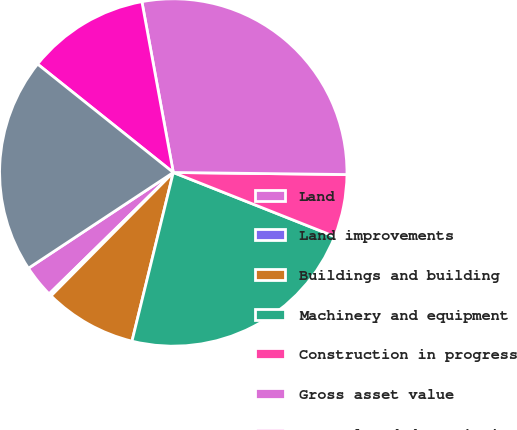<chart> <loc_0><loc_0><loc_500><loc_500><pie_chart><fcel>Land<fcel>Land improvements<fcel>Buildings and building<fcel>Machinery and equipment<fcel>Construction in progress<fcel>Gross asset value<fcel>Accumulated depreciation<fcel>Net book value<nl><fcel>3.03%<fcel>0.25%<fcel>8.6%<fcel>22.81%<fcel>5.82%<fcel>28.08%<fcel>11.38%<fcel>20.02%<nl></chart> 